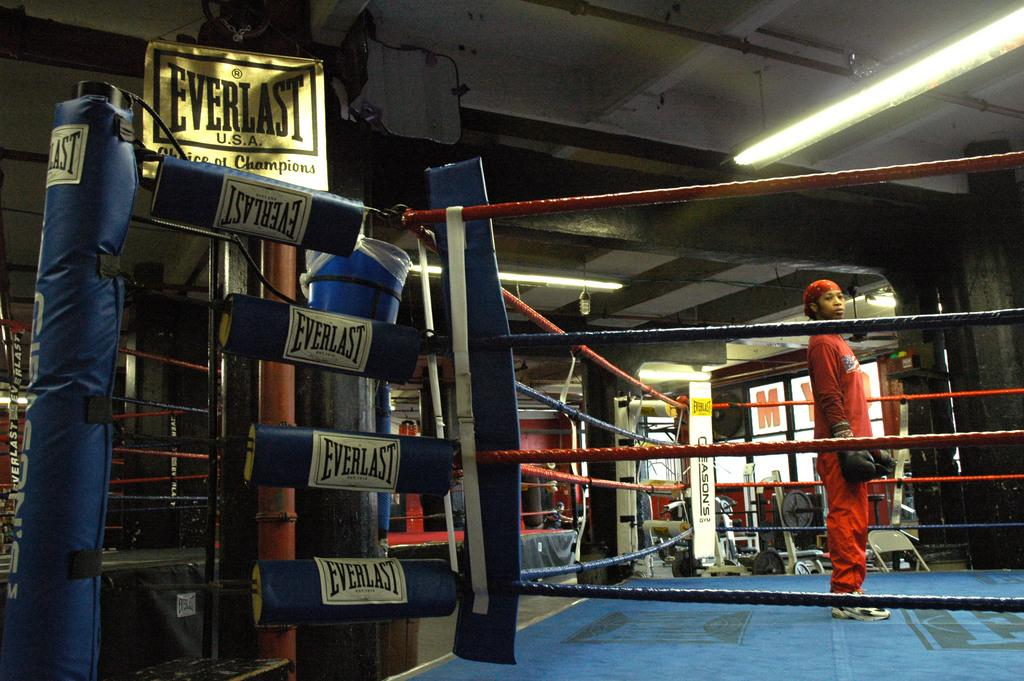Provide a one-sentence caption for the provided image. The boxing ring has pads that read Everlast on them. 